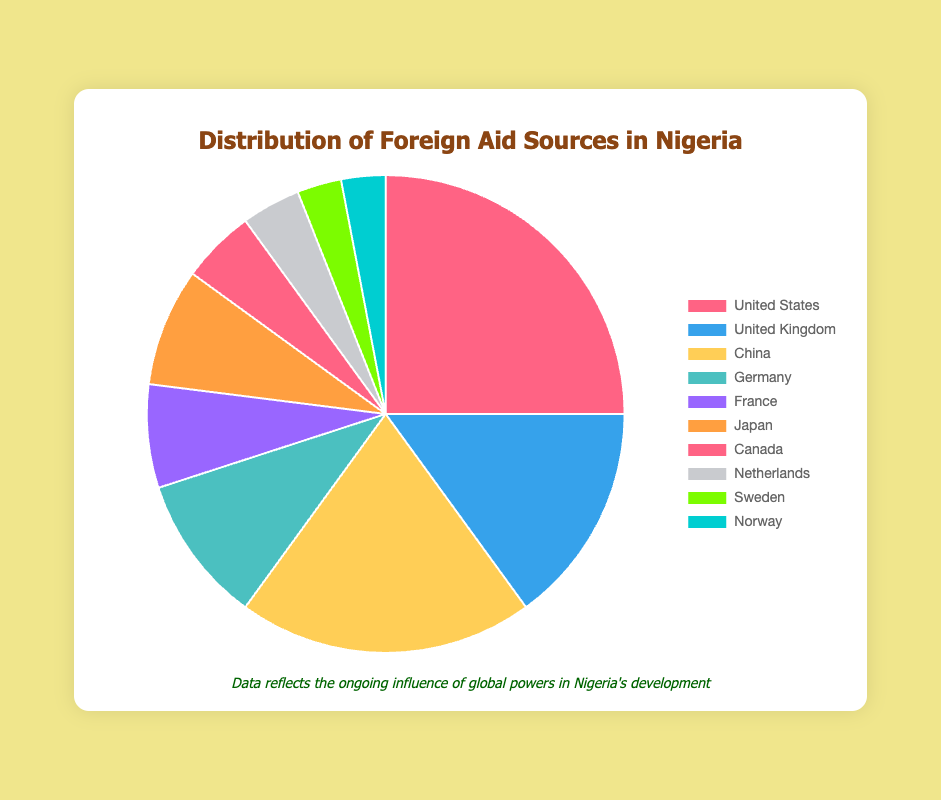What percentage of foreign aid to Nigeria comes from the top three donors? The top three donors are United States (25%), China (20%), and United Kingdom (15%). Adding these together: 25% + 20% + 15% = 60%.
Answer: 60% Which country provides more foreign aid to Nigeria, China or the United Kingdom? The chart shows that China provides 20% of the foreign aid, whereas the United Kingdom provides 15%. Since 20% is greater than 15%, China provides more aid.
Answer: China How much more aid does the United States provide compared to Germany? The United States provides 25% and Germany provides 10%. The difference is 25% - 10% = 15%.
Answer: 15% What is the combined percentage of foreign aid from European countries listed? The European countries listed are the United Kingdom (15%), Germany (10%), France (7%), Netherlands (4%), Sweden (3%), and Norway (3%). Adding these together: 15% + 10% + 7% + 4% + 3% + 3% = 42%.
Answer: 42% Is the aid from Japan more or less than the combined aid from Sweden and Norway? Japan provides 8% of the aid. Sweden and Norway each provide 3%, so their combined contribution is 3% + 3% = 6%. Since 8% is greater than 6%, Japan provides more aid.
Answer: More What is the percentage difference between the aid from France and Canada? France provides 7% of the aid and Canada provides 5%. The difference is 7% - 5% = 2%.
Answer: 2% How does the foreign aid from the Netherlands compare visually to that from Canada? Visually, the segment representing the Netherlands (4%) is smaller in size than the segment representing Canada (5%). This shows that the Netherlands provides less aid than Canada.
Answer: Netherlands provides less If you combine the aid from the United States and Japan, how does it compare to the aid from China and the United Kingdom combined? The United States and Japan combined: 25% + 8% = 33%. China and the United Kingdom combined: 20% + 15% = 35%. Comparing the two sums: 33% < 35%, so China and the United Kingdom combined provide more aid.
Answer: China and the United Kingdom combined Which aid contributors provide the smallest percentages? The smallest percentages of aid are provided by Sweden (3%) and Norway (3%). Both countries provide equal and the smallest amounts of aid on the chart.
Answer: Sweden and Norway 